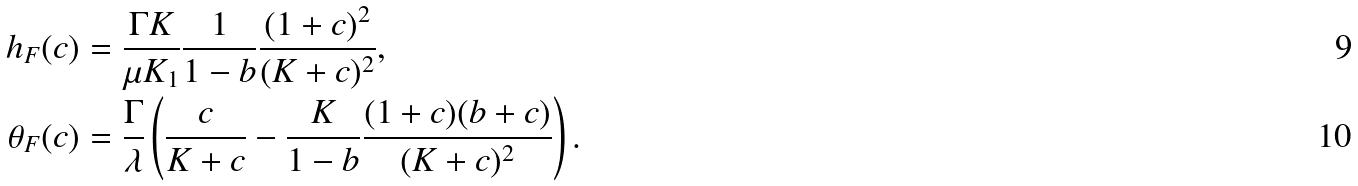<formula> <loc_0><loc_0><loc_500><loc_500>h _ { F } ( c ) & = \frac { \Gamma K } { \mu K _ { 1 } } \frac { 1 } { 1 - b } \frac { ( 1 + c ) ^ { 2 } } { ( K + c ) ^ { 2 } } , \\ \theta _ { F } ( c ) & = \frac { \Gamma } { \lambda } \left ( \frac { c } { K + c } - \frac { K } { 1 - b } \frac { ( 1 + c ) ( b + c ) } { ( K + c ) ^ { 2 } } \right ) .</formula> 